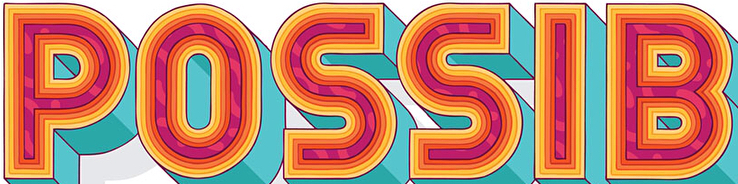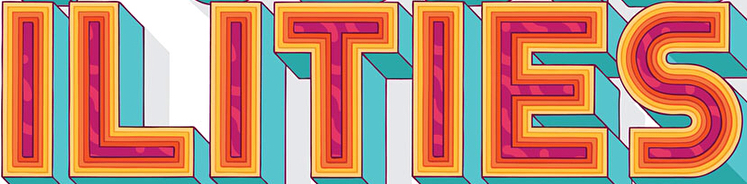Read the text from these images in sequence, separated by a semicolon. POSSIB; ILITIES 